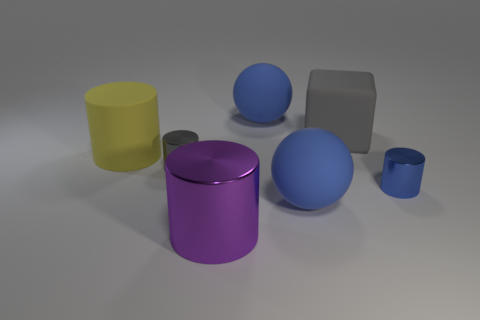What shape is the object that is the same color as the block?
Offer a very short reply. Cylinder. What is the material of the big cylinder that is right of the tiny gray cylinder?
Provide a succinct answer. Metal. What number of gray metal cylinders are to the left of the big object that is left of the large purple metal thing?
Give a very brief answer. 0. Is there a large red matte object that has the same shape as the large purple thing?
Provide a short and direct response. No. Does the blue ball in front of the big yellow matte cylinder have the same size as the blue rubber sphere that is behind the big yellow rubber cylinder?
Give a very brief answer. Yes. There is a blue object that is in front of the small object right of the big metallic object; what shape is it?
Provide a short and direct response. Sphere. How many other yellow matte objects are the same size as the yellow object?
Provide a short and direct response. 0. Are there any yellow matte cylinders?
Keep it short and to the point. Yes. Is there any other thing that has the same color as the big metal cylinder?
Make the answer very short. No. There is a large yellow object that is made of the same material as the cube; what is its shape?
Your answer should be compact. Cylinder. 